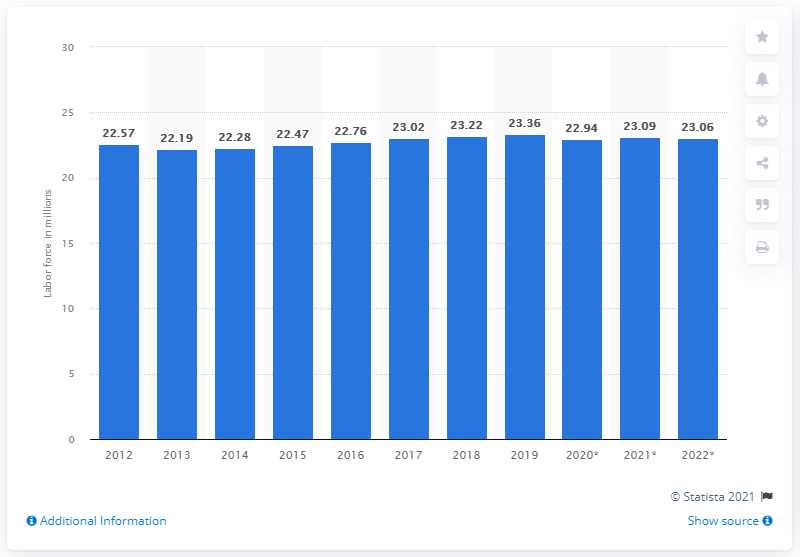Give some essential details in this illustration. In 2012, the labor force of Italy was approximately 23.36 million people. In 2019, Italy's labor force was 23.36 million. 